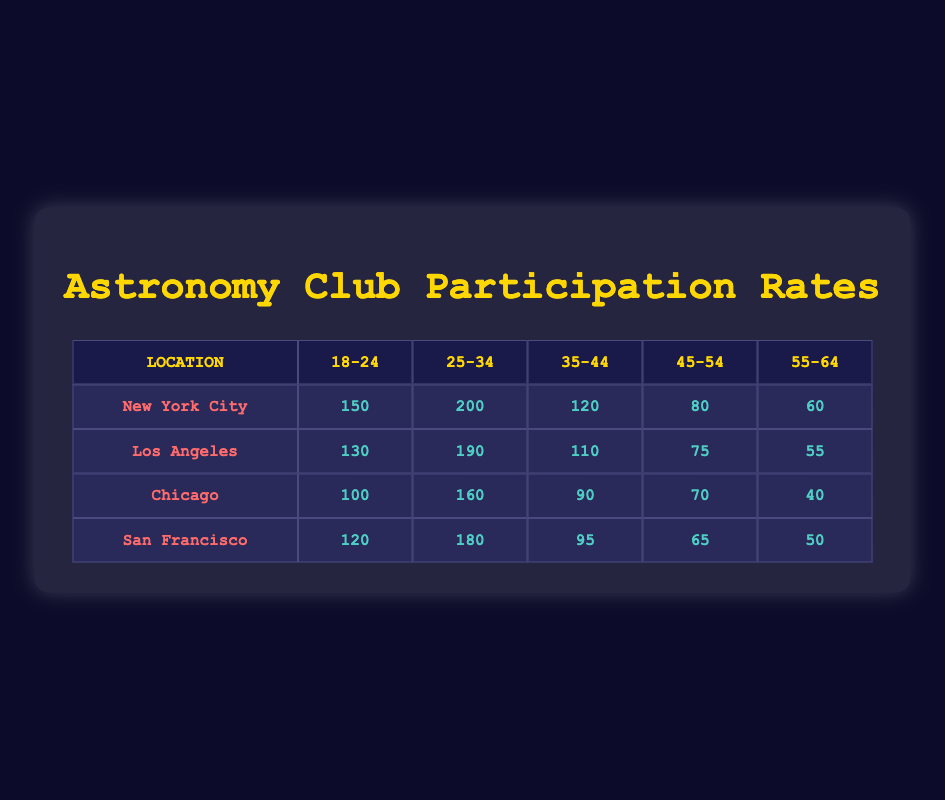What is the highest number of participants in a single age group in New York City? In the New York City row, the age groups are: 18-24 has 150, 25-34 has 200, 35-44 has 120, 45-54 has 80, and 55-64 has 60. The highest number among these is 200 in the 25-34 age group.
Answer: 200 Which city has the least participation among the 55-64 age group? Looking at the 55-64 age group across the cities: New York City has 60, Los Angeles has 55, Chicago has 40, and San Francisco has 50. The least participation is observed in Chicago with 40 participants.
Answer: Chicago What is the total number of participants aged 18-24 across all cities? The participants aged 18-24 in each city are: New York City has 150, Los Angeles has 130, Chicago has 100, and San Francisco has 120. Summing these gives: 150 + 130 + 100 + 120 = 500.
Answer: 500 Is it true that Los Angeles has more participants in the age group 25-34 than New York City? In Los Angeles, the participants aged 25-34 are 190, while in New York City, there are 200 participants in the same age group. Since 190 is less than 200, the statement is false.
Answer: No What is the average number of participants across all cities for the age group 45-54? The participants for the age group 45-54 are: New York City has 80, Los Angeles has 75, Chicago has 70, and San Francisco has 65. To find the average, add these: 80 + 75 + 70 + 65 = 290, and then divide by 4 (the number of cities): 290 / 4 = 72.5.
Answer: 72.5 Which age group in Chicago had the highest number of participants? The age groups in Chicago and their participants are: 18-24 has 100, 25-34 has 160, 35-44 has 90, 45-54 has 70, and 55-64 has 40. The highest value among these is 160 in the 25-34 age group.
Answer: 25-34 Calculate the difference in participants between the 18-24 age group in New York City and Chicago. In New York City, the number of participants in the 18-24 age group is 150, and in Chicago, it is 100. To find the difference, subtract Chicago’s participants from New York City’s: 150 - 100 = 50.
Answer: 50 What percentage of the total participants aged 35-44 in San Francisco compared to New York City? The number of participants aged 35-44 in San Francisco is 95, while in New York City, it is 120. To find the percentage, first find the ratio: 95 / 120 = 0.79167, then multiply by 100 to convert it to a percentage: 0.79167 * 100 ≈ 79.17%.
Answer: 79.17% 